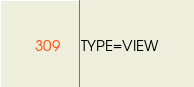<code> <loc_0><loc_0><loc_500><loc_500><_VisualBasic_>TYPE=VIEW</code> 